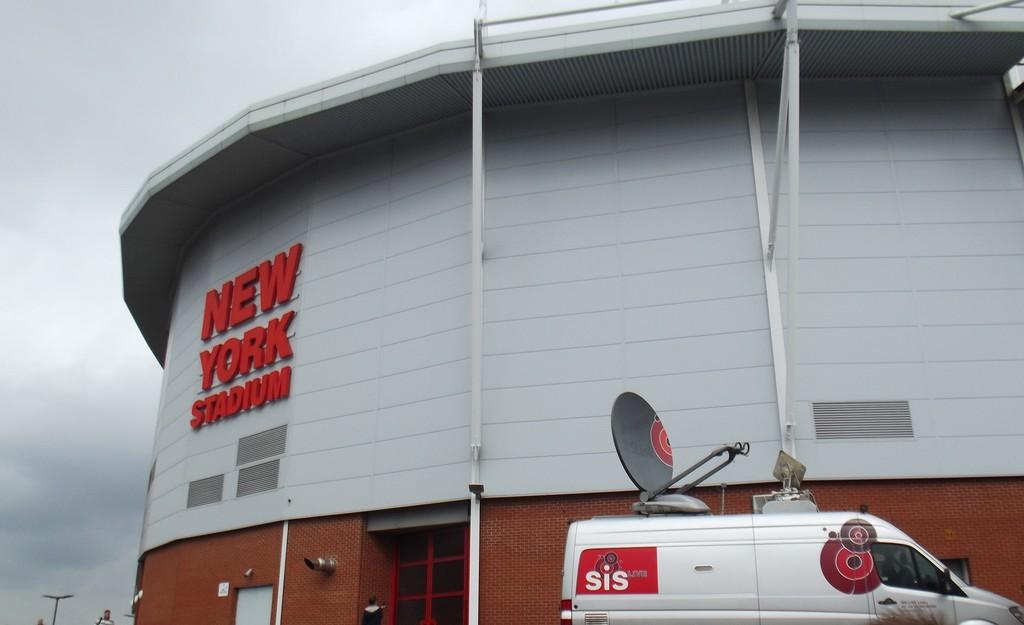<image>
Describe the image concisely. A large rounded building that is wood and brick has the name NEW YORK STADIUM on the front of the building. 